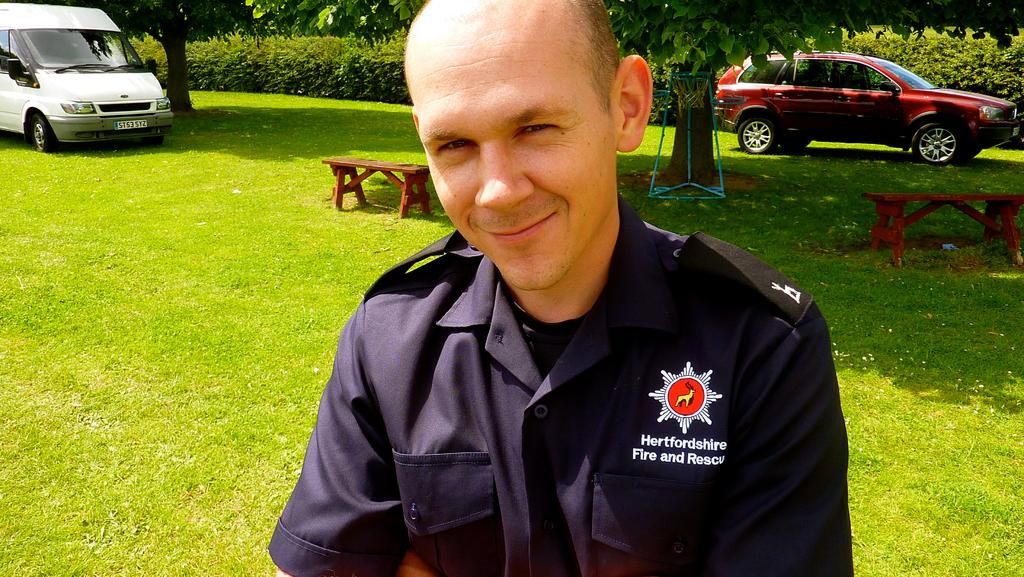Who is present in the image? There is a man in the picture. What is the man doing in the image? The man is smiling in the image. What is the man wearing in the image? The man is wearing a uniform in the image. What can be seen in the background of the picture? There are trees, a car, a van, and two benches on the grass in the background of the picture. What type of scissors can be seen in the man's hand in the image? There are no scissors present in the man's hand or anywhere in the image. Is the man riding a bike in the image? No, the man is not riding a bike in the image; he is standing and smiling. 